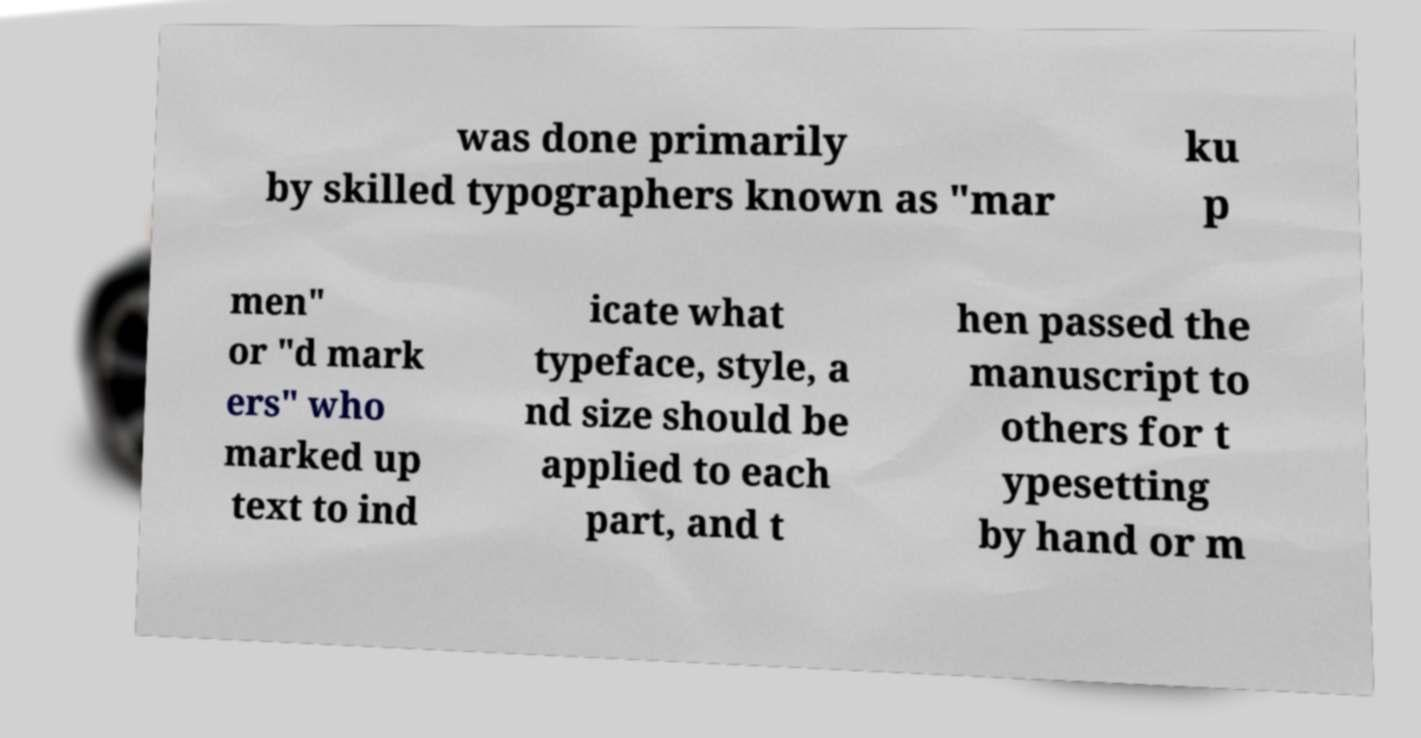Can you read and provide the text displayed in the image?This photo seems to have some interesting text. Can you extract and type it out for me? was done primarily by skilled typographers known as "mar ku p men" or "d mark ers" who marked up text to ind icate what typeface, style, a nd size should be applied to each part, and t hen passed the manuscript to others for t ypesetting by hand or m 